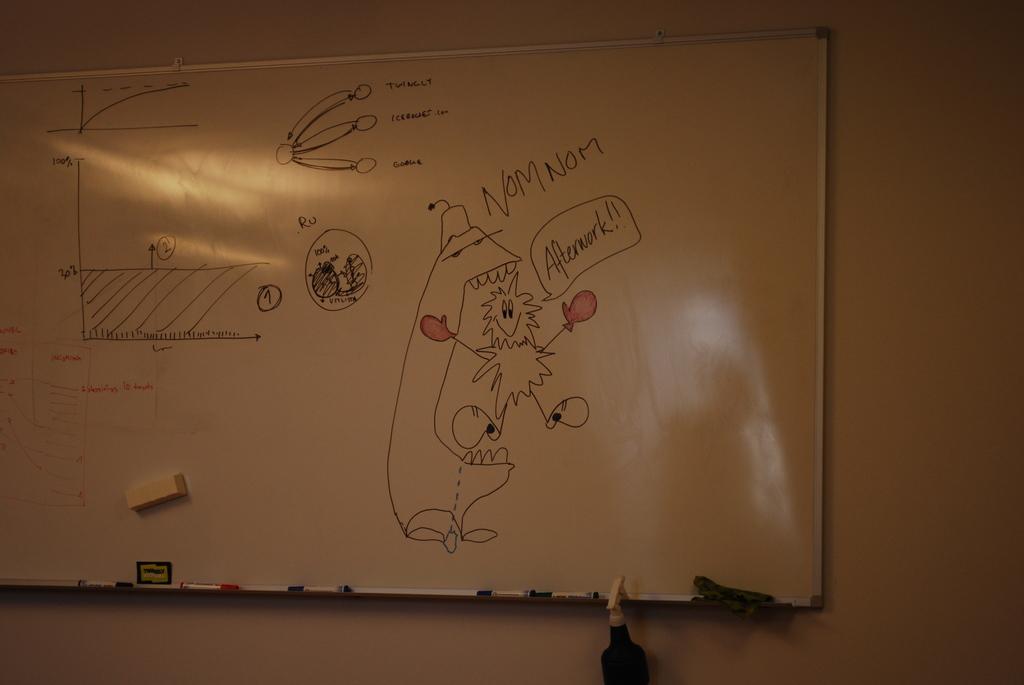What is the small creature who is getting eaten saying?
Offer a terse response. Afterwork!!. What is the large creature saying?
Your response must be concise. Nom nom. 